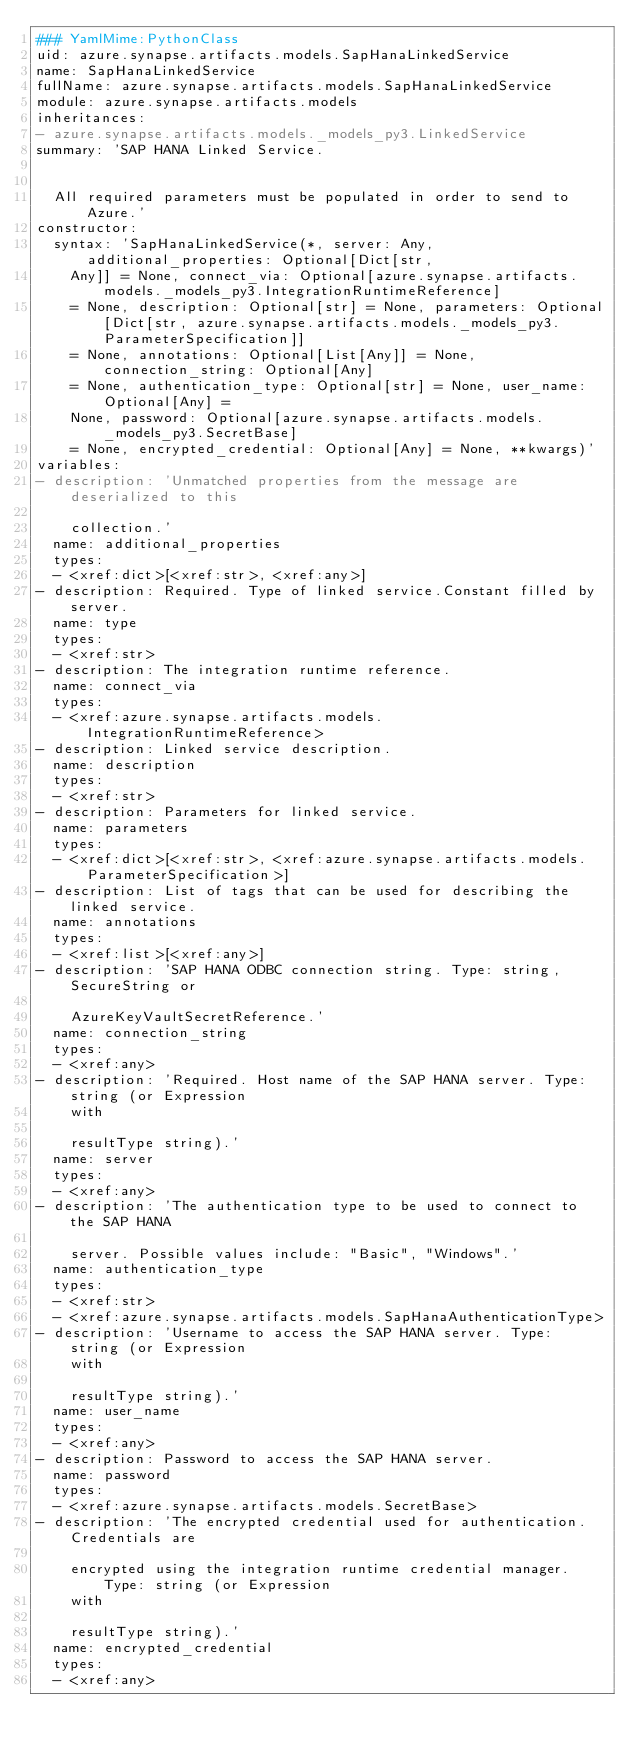Convert code to text. <code><loc_0><loc_0><loc_500><loc_500><_YAML_>### YamlMime:PythonClass
uid: azure.synapse.artifacts.models.SapHanaLinkedService
name: SapHanaLinkedService
fullName: azure.synapse.artifacts.models.SapHanaLinkedService
module: azure.synapse.artifacts.models
inheritances:
- azure.synapse.artifacts.models._models_py3.LinkedService
summary: 'SAP HANA Linked Service.


  All required parameters must be populated in order to send to Azure.'
constructor:
  syntax: 'SapHanaLinkedService(*, server: Any, additional_properties: Optional[Dict[str,
    Any]] = None, connect_via: Optional[azure.synapse.artifacts.models._models_py3.IntegrationRuntimeReference]
    = None, description: Optional[str] = None, parameters: Optional[Dict[str, azure.synapse.artifacts.models._models_py3.ParameterSpecification]]
    = None, annotations: Optional[List[Any]] = None, connection_string: Optional[Any]
    = None, authentication_type: Optional[str] = None, user_name: Optional[Any] =
    None, password: Optional[azure.synapse.artifacts.models._models_py3.SecretBase]
    = None, encrypted_credential: Optional[Any] = None, **kwargs)'
variables:
- description: 'Unmatched properties from the message are deserialized to this

    collection.'
  name: additional_properties
  types:
  - <xref:dict>[<xref:str>, <xref:any>]
- description: Required. Type of linked service.Constant filled by server.
  name: type
  types:
  - <xref:str>
- description: The integration runtime reference.
  name: connect_via
  types:
  - <xref:azure.synapse.artifacts.models.IntegrationRuntimeReference>
- description: Linked service description.
  name: description
  types:
  - <xref:str>
- description: Parameters for linked service.
  name: parameters
  types:
  - <xref:dict>[<xref:str>, <xref:azure.synapse.artifacts.models.ParameterSpecification>]
- description: List of tags that can be used for describing the linked service.
  name: annotations
  types:
  - <xref:list>[<xref:any>]
- description: 'SAP HANA ODBC connection string. Type: string, SecureString or

    AzureKeyVaultSecretReference.'
  name: connection_string
  types:
  - <xref:any>
- description: 'Required. Host name of the SAP HANA server. Type: string (or Expression
    with

    resultType string).'
  name: server
  types:
  - <xref:any>
- description: 'The authentication type to be used to connect to the SAP HANA

    server. Possible values include: "Basic", "Windows".'
  name: authentication_type
  types:
  - <xref:str>
  - <xref:azure.synapse.artifacts.models.SapHanaAuthenticationType>
- description: 'Username to access the SAP HANA server. Type: string (or Expression
    with

    resultType string).'
  name: user_name
  types:
  - <xref:any>
- description: Password to access the SAP HANA server.
  name: password
  types:
  - <xref:azure.synapse.artifacts.models.SecretBase>
- description: 'The encrypted credential used for authentication. Credentials are

    encrypted using the integration runtime credential manager. Type: string (or Expression
    with

    resultType string).'
  name: encrypted_credential
  types:
  - <xref:any>
</code> 